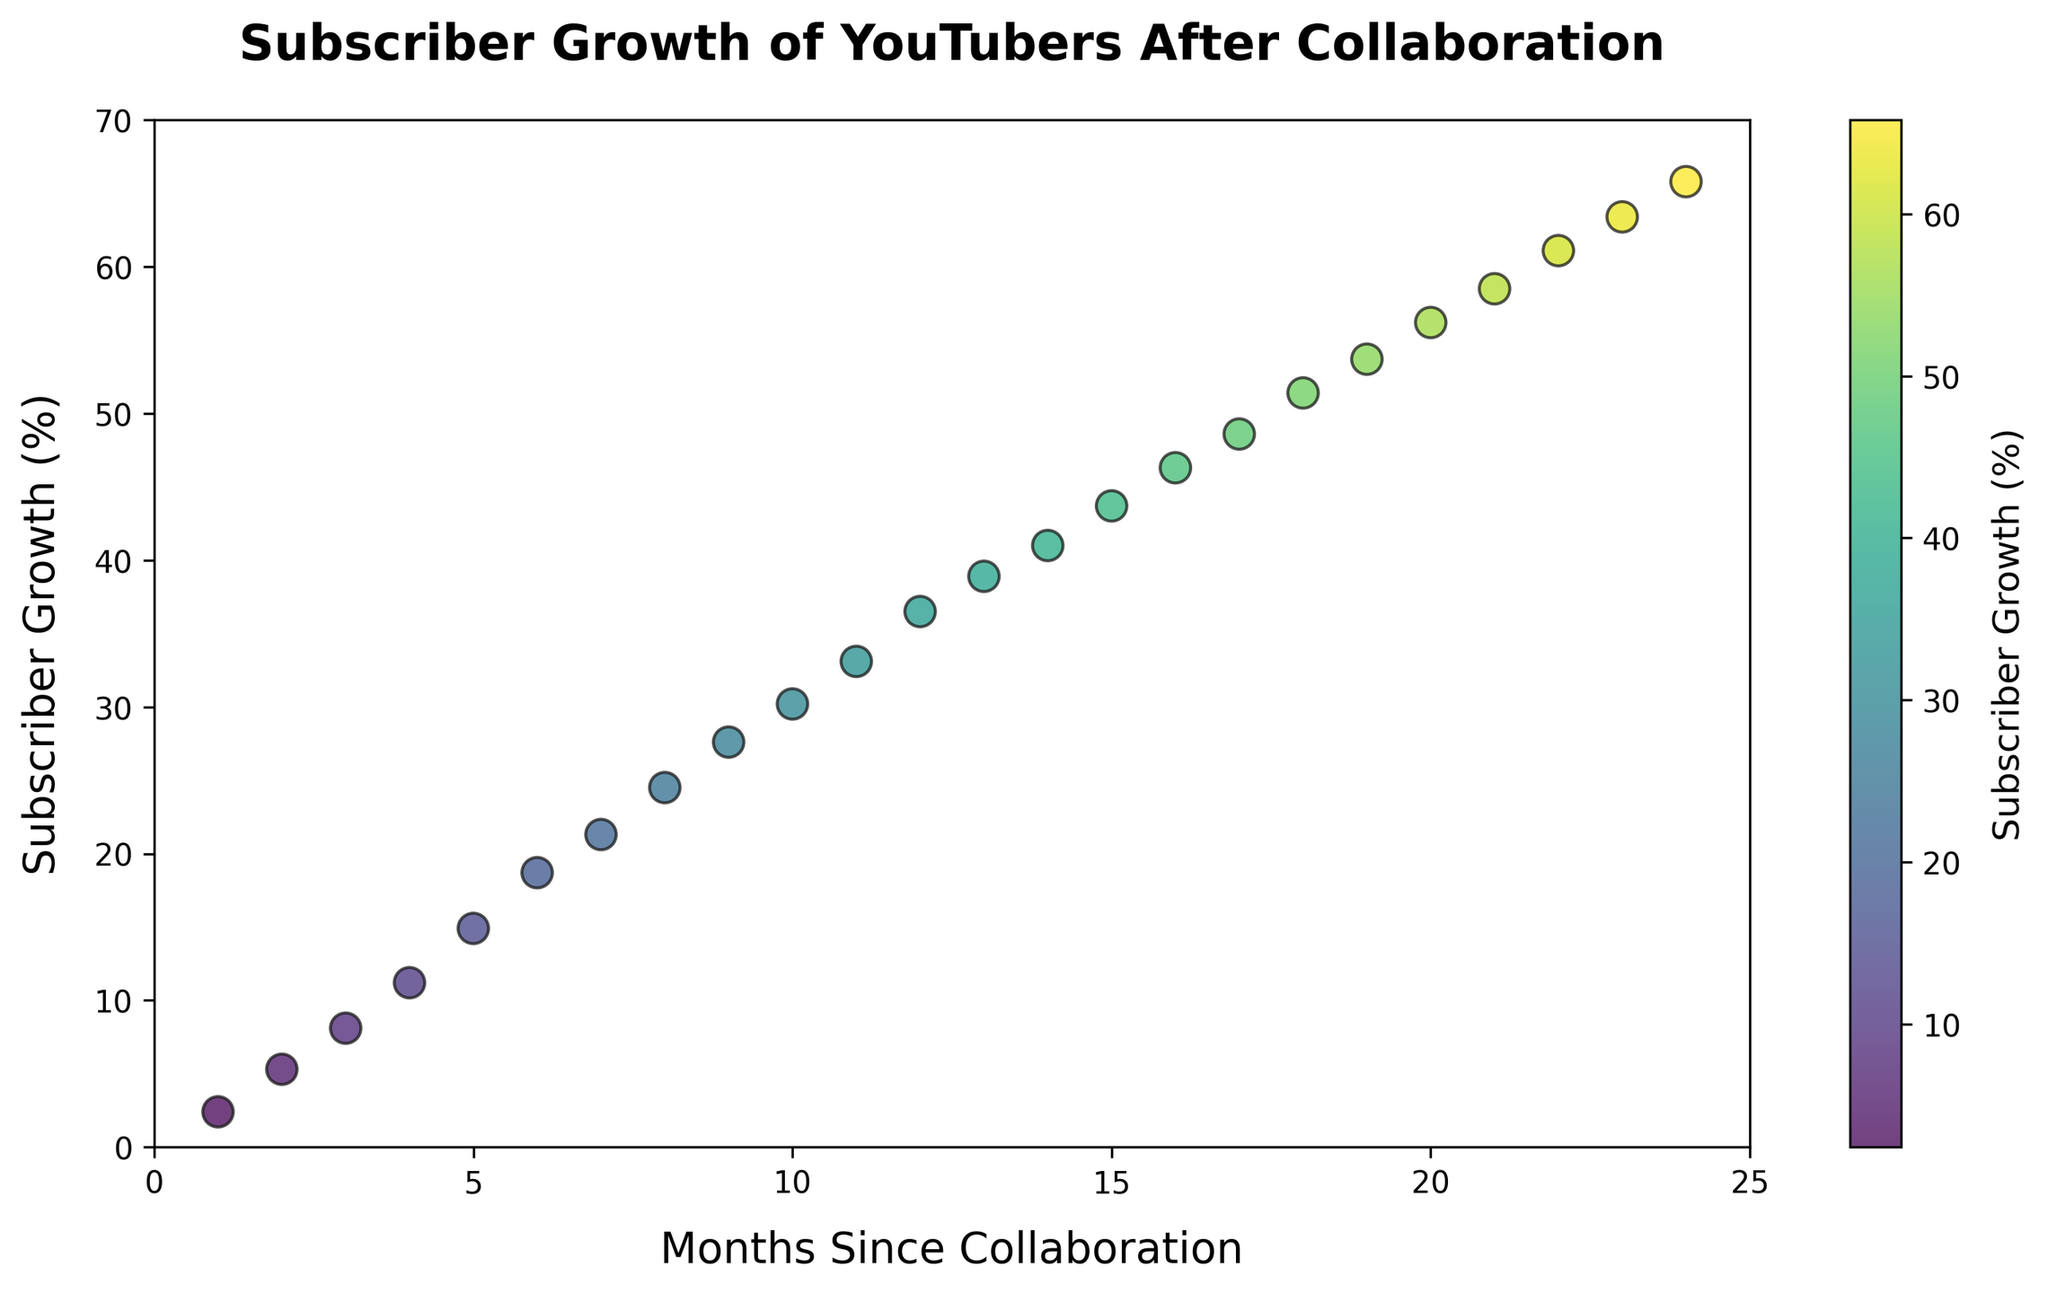What's the trend of subscriber growth over time after collaboration? The scatter plot shows an increasing trend in subscriber growth over the months following the collaboration. The plot starts with small growth percentages and grows steadily, reaching higher percentages in later months. The colors transitioning from lighter to darker toward higher values also support this.
Answer: Increasing trend How much was the subscriber growth at the 12th month compared to the 6th month? According to the plot, the subscriber growth at the 12th month is roughly 36.5%, whereas at the 6th month, it's approximately 18.7%. To find the difference, subtract the growth value at the 6th month from the 12th month: 36.5% - 18.7% = 17.8%.
Answer: 17.8% Between which months did the subscriber growth see the most significant increase? By comparing the distances between the data points on the y-axis, the most significant jump appears between months 6 and 7, where the growth increases from 18.7% to 21.3%. The exact difference is 21.3% - 18.7% = 2.6%.
Answer: Months 6 and 7 Is the subscriber growth steady, decreasing, or accelerating? The scatter plot shows that the increments in subscriber growth become larger over time. For example, the difference in growth between each consecutive month towards the beginning is smaller compared to differences towards the end, indicating that growth is accelerating.
Answer: Accelerating What is the subscriber growth percentage at 18 months? According to the scatter plot, the subscriber growth percentage at 18 months is approximately 51.4%.
Answer: 51.4% How does the growth at 8 months compare visually to the growth at 20 months? Pointing to the scatter plot, the subscriber growth percentage at 8 months is about 24.5%, while at 20 months, it is around 56.2%. The latter point is both significantly higher and darker in color on the viridis color map, indicating higher growth.
Answer: 20 months > 8 months What is the mean subscriber growth percentage over 24 months? To calculate the mean growth over 24 months, sum the growth percentages for all 24 months and divide by 24. (2.4 + 5.3 + 8.1 + 11.2 + 14.9 + 18.7 + 21.3 + 24.5 + 27.6 + 30.2 + 33.1 + 36.5 + 38.9 + 41.0 + 43.7 + 46.3 + 48.6 + 51.4 + 53.7 + 56.2 + 58.5 + 61.1 + 63.4 + 65.8) / 24 = 35.7%
Answer: 35.7% By how many percentage points did the growth increase in the 24th month compared to the first month? The scatter plot indicates the subscriber growth in the first month is 2.4% and in the 24th month is 65.8%. The increase is calculated as 65.8% - 2.4% = 63.4%.
Answer: 63.4% Is there a point where the growth rate appears to plateau or slow down? Visually inspecting the scatter plot, there is no significant plateau or slowdown; the growth continues to increase over the 24 months but could be potentially slower in the later months compared to the overall acceleration seen earlier. Specific details on the plateau would require more detailed analysis beyond the visual inspection.
Answer: No significant plateau 